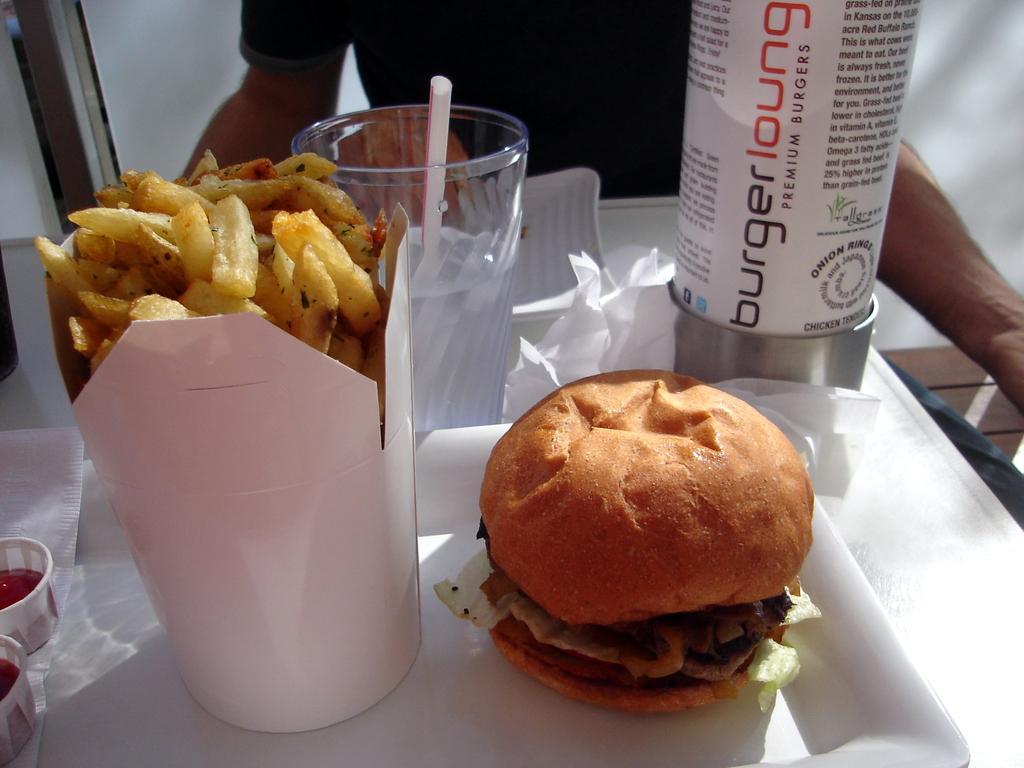In one or two sentences, can you explain what this image depicts? In this image in front there is a table. On top of it there is a burger. There are french fries on a tray. There are sauces. There is a glass with straw in it. There are are tissues and a few other objects. In front of the table there is a person sitting on the bench. In the background of the image there is a wall. At the bottom of the image there is a floor. 